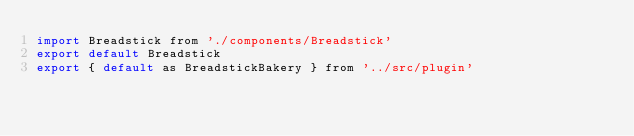Convert code to text. <code><loc_0><loc_0><loc_500><loc_500><_JavaScript_>import Breadstick from './components/Breadstick'
export default Breadstick
export { default as BreadstickBakery } from '../src/plugin'
</code> 